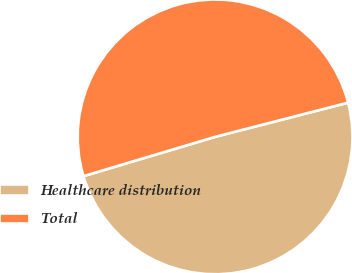Convert chart. <chart><loc_0><loc_0><loc_500><loc_500><pie_chart><fcel>Healthcare distribution<fcel>Total<nl><fcel>49.39%<fcel>50.61%<nl></chart> 